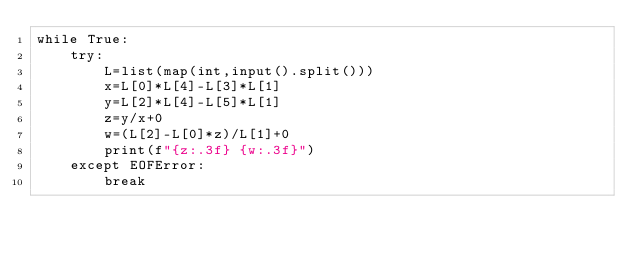<code> <loc_0><loc_0><loc_500><loc_500><_Python_>while True:
    try:
        L=list(map(int,input().split()))
        x=L[0]*L[4]-L[3]*L[1]
        y=L[2]*L[4]-L[5]*L[1]
        z=y/x+0
        w=(L[2]-L[0]*z)/L[1]+0
        print(f"{z:.3f} {w:.3f}")
    except EOFError:
        break
</code> 